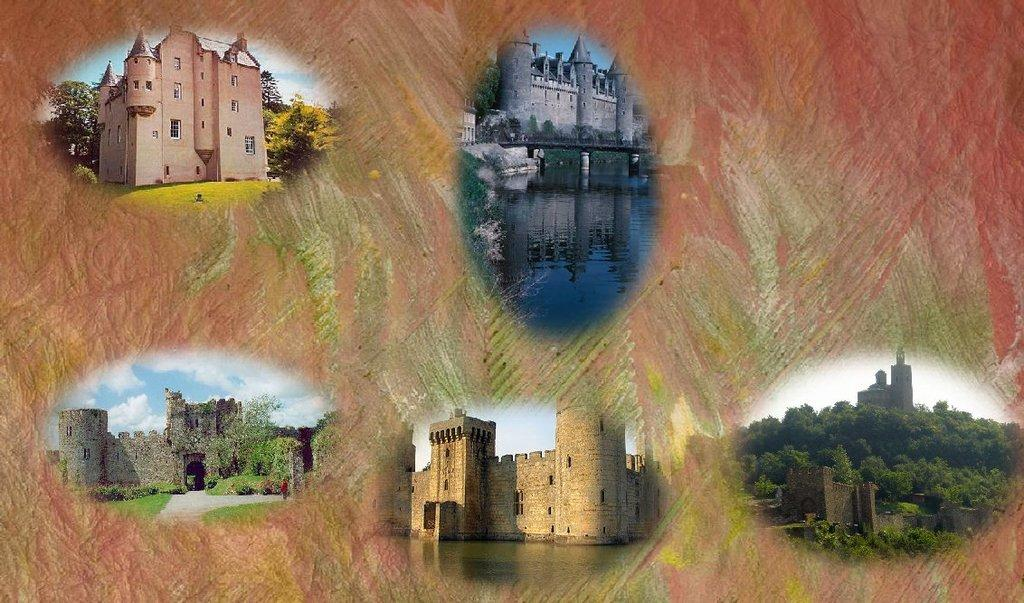What type of structures can be seen in the image? There are buildings in the image. What type of vegetation is present in the image? There are trees and forests in the image. What natural element can be seen in the image? There is water visible in the image. How many passengers are visible in the image? There are no passengers present in the image. What type of animal can be seen grazing in the image? There are no animals, such as cows, present in the image. What type of coil can be seen in the image? There is no coil present in the image. 